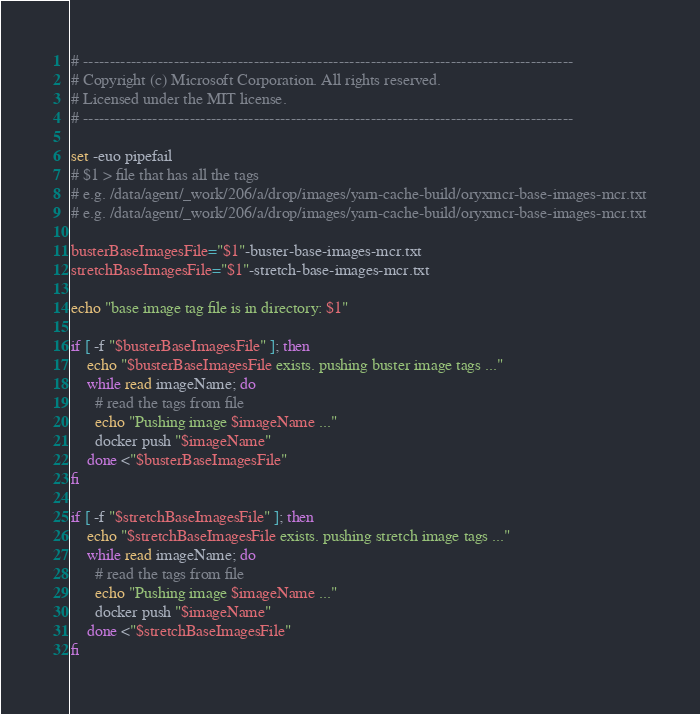<code> <loc_0><loc_0><loc_500><loc_500><_Bash_># --------------------------------------------------------------------------------------------
# Copyright (c) Microsoft Corporation. All rights reserved.
# Licensed under the MIT license.
# --------------------------------------------------------------------------------------------

set -euo pipefail
# $1 > file that has all the tags 
# e.g. /data/agent/_work/206/a/drop/images/yarn-cache-build/oryxmcr-base-images-mcr.txt
# e.g. /data/agent/_work/206/a/drop/images/yarn-cache-build/oryxmcr-base-images-mcr.txt

busterBaseImagesFile="$1"-buster-base-images-mcr.txt
stretchBaseImagesFile="$1"-stretch-base-images-mcr.txt

echo "base image tag file is in directory: $1"

if [ -f "$busterBaseImagesFile" ]; then
    echo "$busterBaseImagesFile exists. pushing buster image tags ..."
    while read imageName; do
      # read the tags from file
      echo "Pushing image $imageName ..."
      docker push "$imageName"
    done <"$busterBaseImagesFile"
fi

if [ -f "$stretchBaseImagesFile" ]; then
    echo "$stretchBaseImagesFile exists. pushing stretch image tags ..."
    while read imageName; do
      # read the tags from file
      echo "Pushing image $imageName ..."
      docker push "$imageName"
    done <"$stretchBaseImagesFile"
fi

</code> 